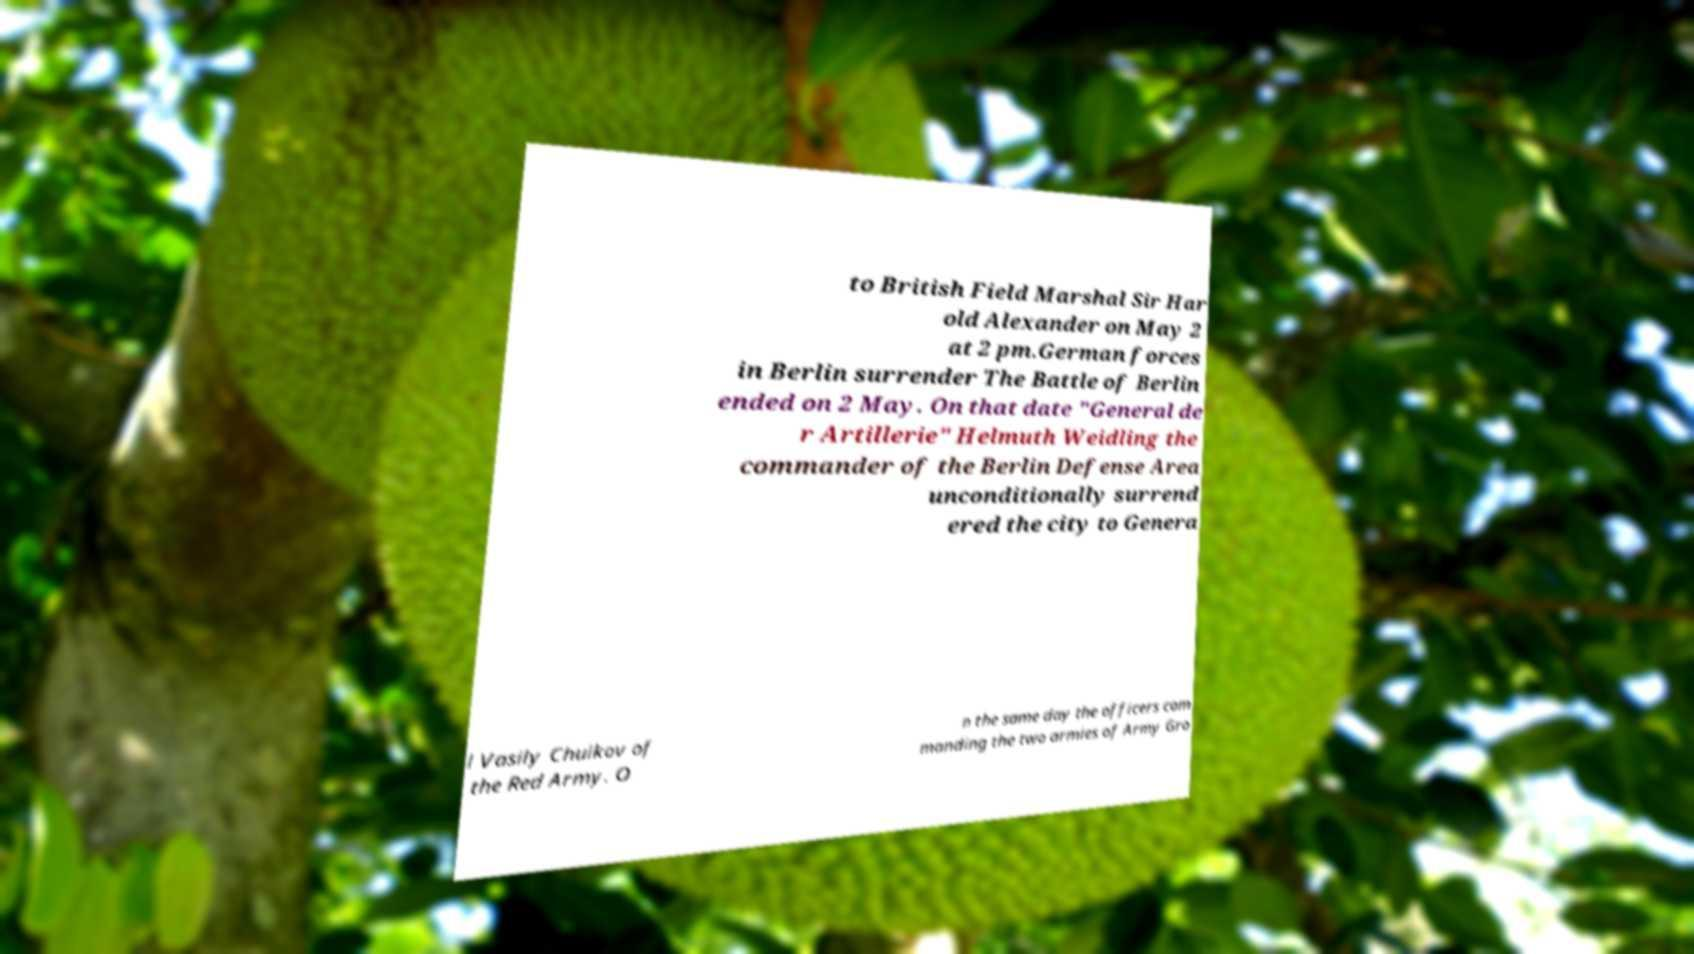Can you read and provide the text displayed in the image?This photo seems to have some interesting text. Can you extract and type it out for me? to British Field Marshal Sir Har old Alexander on May 2 at 2 pm.German forces in Berlin surrender The Battle of Berlin ended on 2 May. On that date "General de r Artillerie" Helmuth Weidling the commander of the Berlin Defense Area unconditionally surrend ered the city to Genera l Vasily Chuikov of the Red Army. O n the same day the officers com manding the two armies of Army Gro 